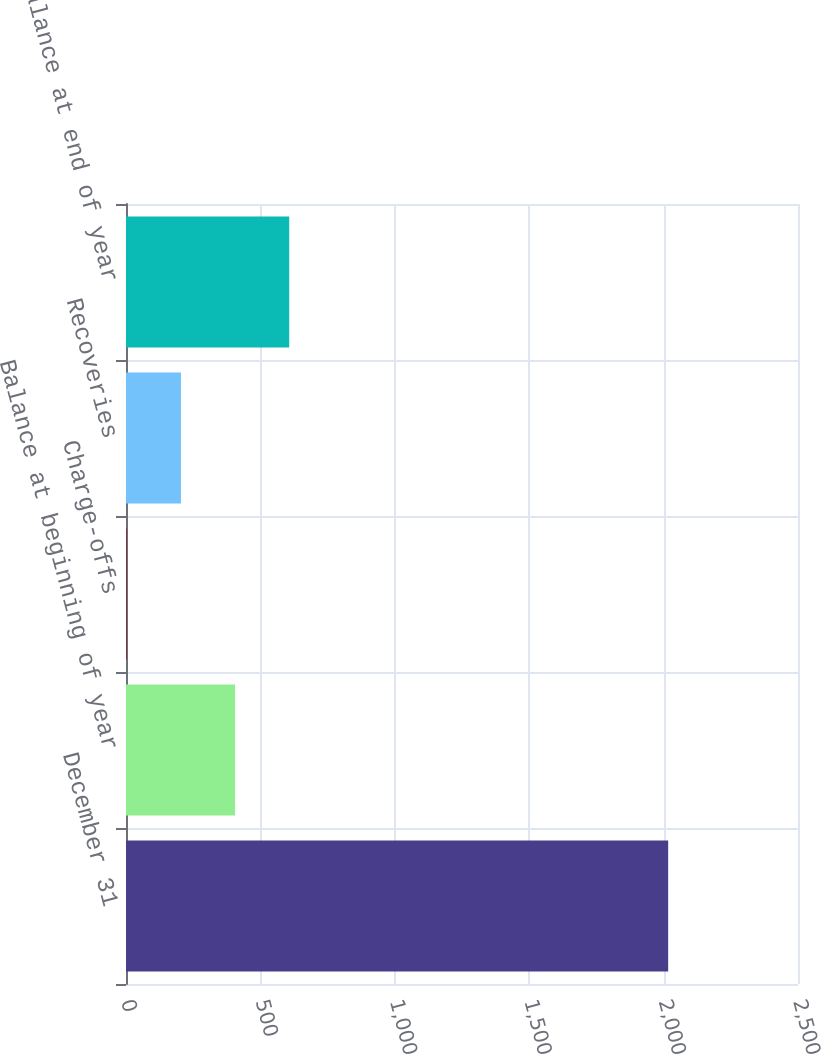<chart> <loc_0><loc_0><loc_500><loc_500><bar_chart><fcel>December 31<fcel>Balance at beginning of year<fcel>Charge-offs<fcel>Recoveries<fcel>Balance at end of year<nl><fcel>2017<fcel>405.8<fcel>3<fcel>204.4<fcel>607.2<nl></chart> 